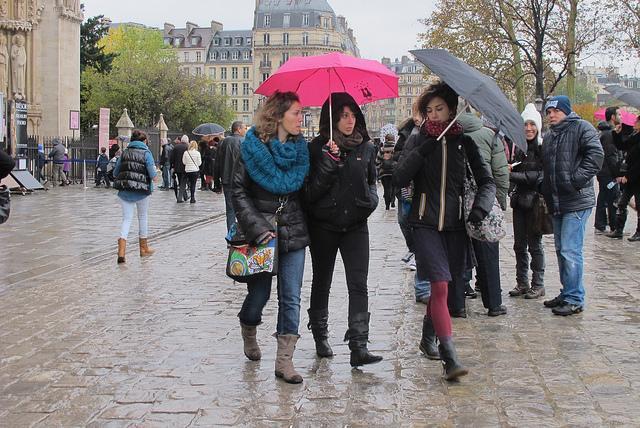How many umbrellas are there?
Give a very brief answer. 4. How many colors are in the umbrella being held over the group's heads?
Give a very brief answer. 1. How many umbrellas are in the picture?
Give a very brief answer. 5. How many people are visible?
Give a very brief answer. 9. How many umbrellas are in the photo?
Give a very brief answer. 2. How many giraffes are in the cage?
Give a very brief answer. 0. 